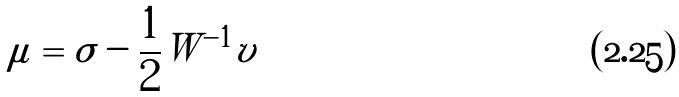<formula> <loc_0><loc_0><loc_500><loc_500>\mu = \sigma - \frac { 1 } { 2 } W ^ { - 1 } v</formula> 